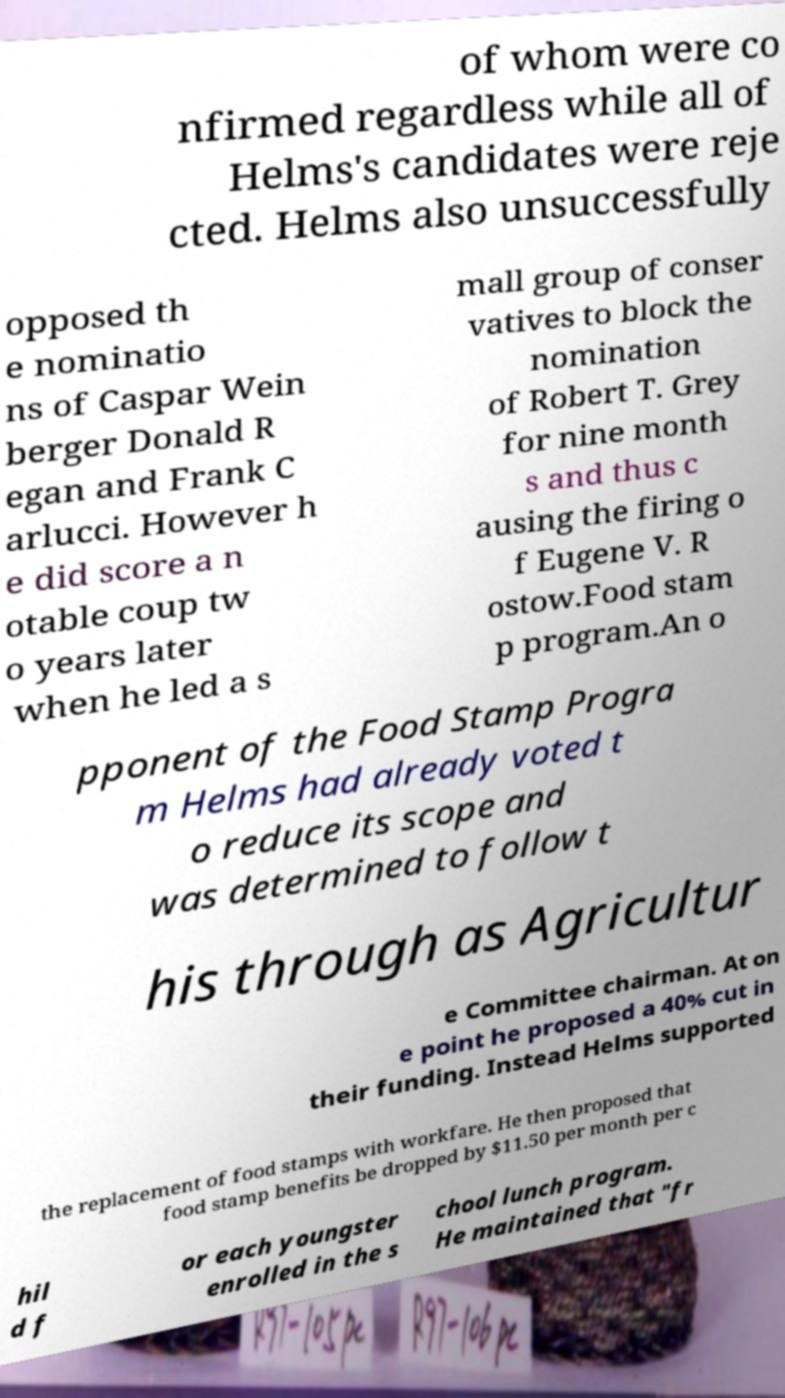Could you extract and type out the text from this image? of whom were co nfirmed regardless while all of Helms's candidates were reje cted. Helms also unsuccessfully opposed th e nominatio ns of Caspar Wein berger Donald R egan and Frank C arlucci. However h e did score a n otable coup tw o years later when he led a s mall group of conser vatives to block the nomination of Robert T. Grey for nine month s and thus c ausing the firing o f Eugene V. R ostow.Food stam p program.An o pponent of the Food Stamp Progra m Helms had already voted t o reduce its scope and was determined to follow t his through as Agricultur e Committee chairman. At on e point he proposed a 40% cut in their funding. Instead Helms supported the replacement of food stamps with workfare. He then proposed that food stamp benefits be dropped by $11.50 per month per c hil d f or each youngster enrolled in the s chool lunch program. He maintained that "fr 